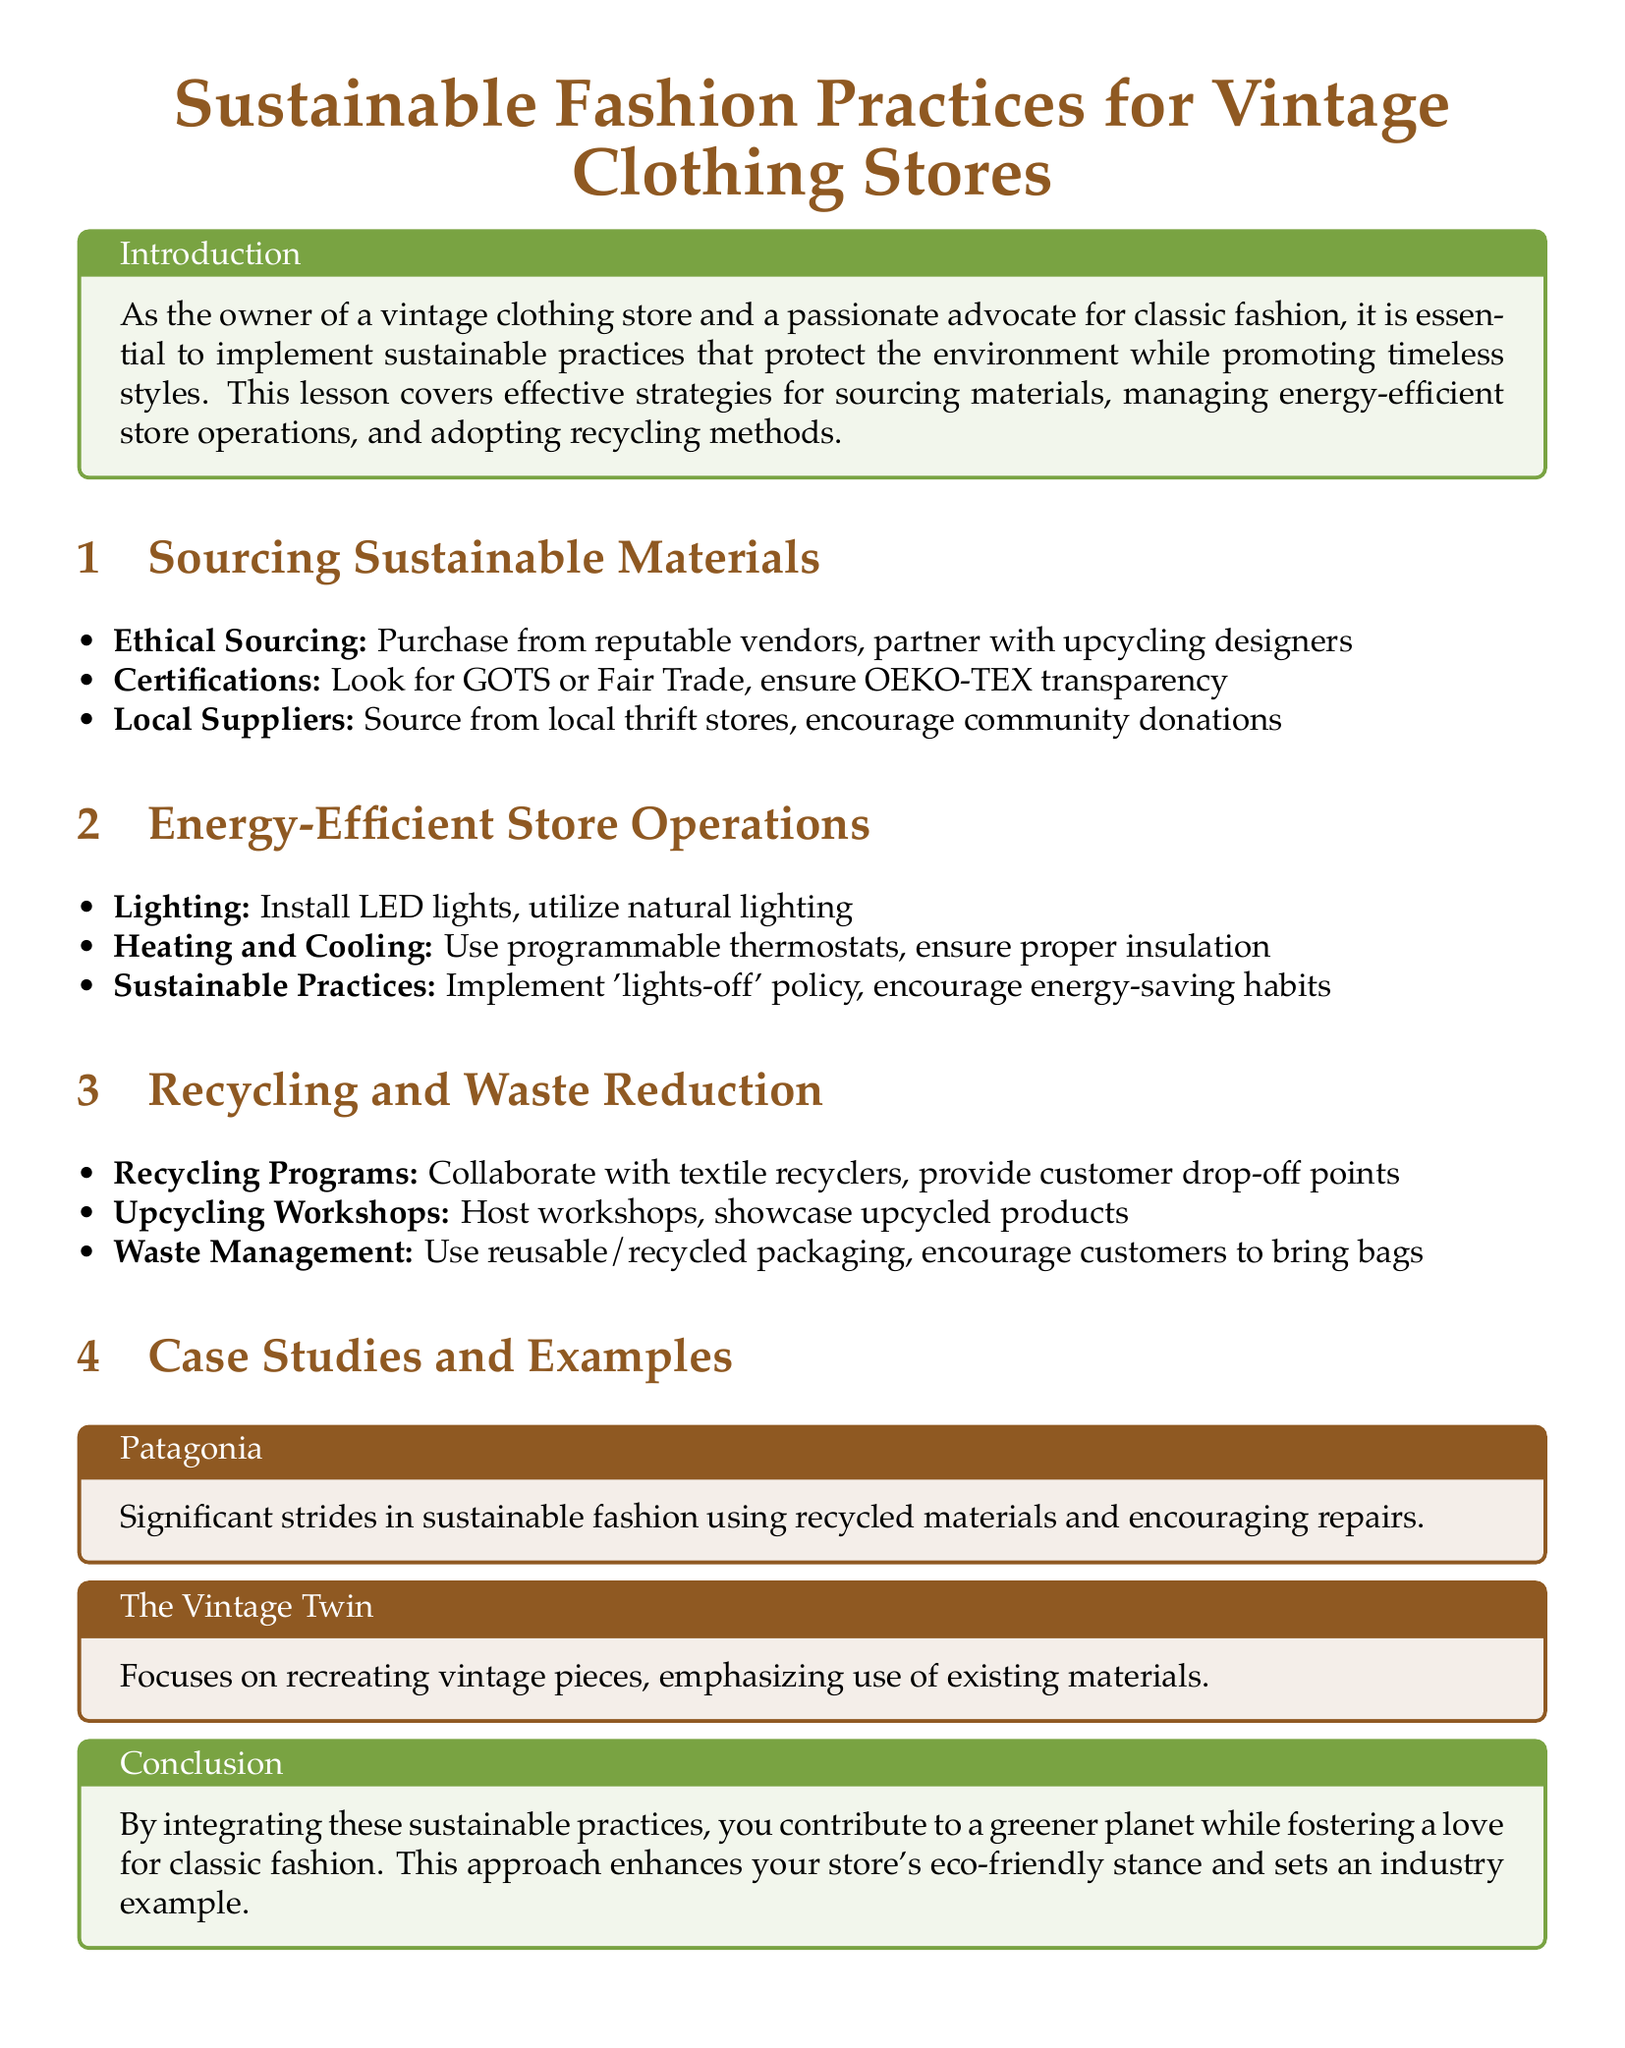What is the title of the document? The title is found at the beginning of the document, which identifies the main topic.
Answer: Sustainable Fashion Practices for Vintage Clothing Stores What type of materials should be sourced according to the lesson plan? The lesson discusses the importance of ethical sourcing, highlighting the need for integrity and transparency in material selection.
Answer: Sustainable materials Which lighting solution is recommended for the store? The document suggests specific energy-efficient solutions aimed at reducing environmental impact in store operations.
Answer: LED lights What does Patagonia emphasize in its case study? The case study describes Patagonia’s significant achievement in sustainable practices, particularly in the area of material sourcing.
Answer: Recycled materials What is one action suggested to reduce waste? The document lists methods for waste management and recycling, focusing on practical steps to minimize waste in store operations.
Answer: Use reusable/recycled packaging Which thermostat approach is recommended for energy efficiency? Energy-efficient heating and cooling methods are outlined, which can influence overall store energy consumption.
Answer: Programmable thermostats What organization’s certifications should be sought for sourcing materials? The document mentions certifications that provide guarantees for sustainable practices during sourcing of materials.
Answer: GOTS or Fair Trade What approach does The Vintage Twin emphasize? The case study provides insights on creative re-use, showcasing their focus on sustainability through specific practices.
Answer: Use of existing materials 